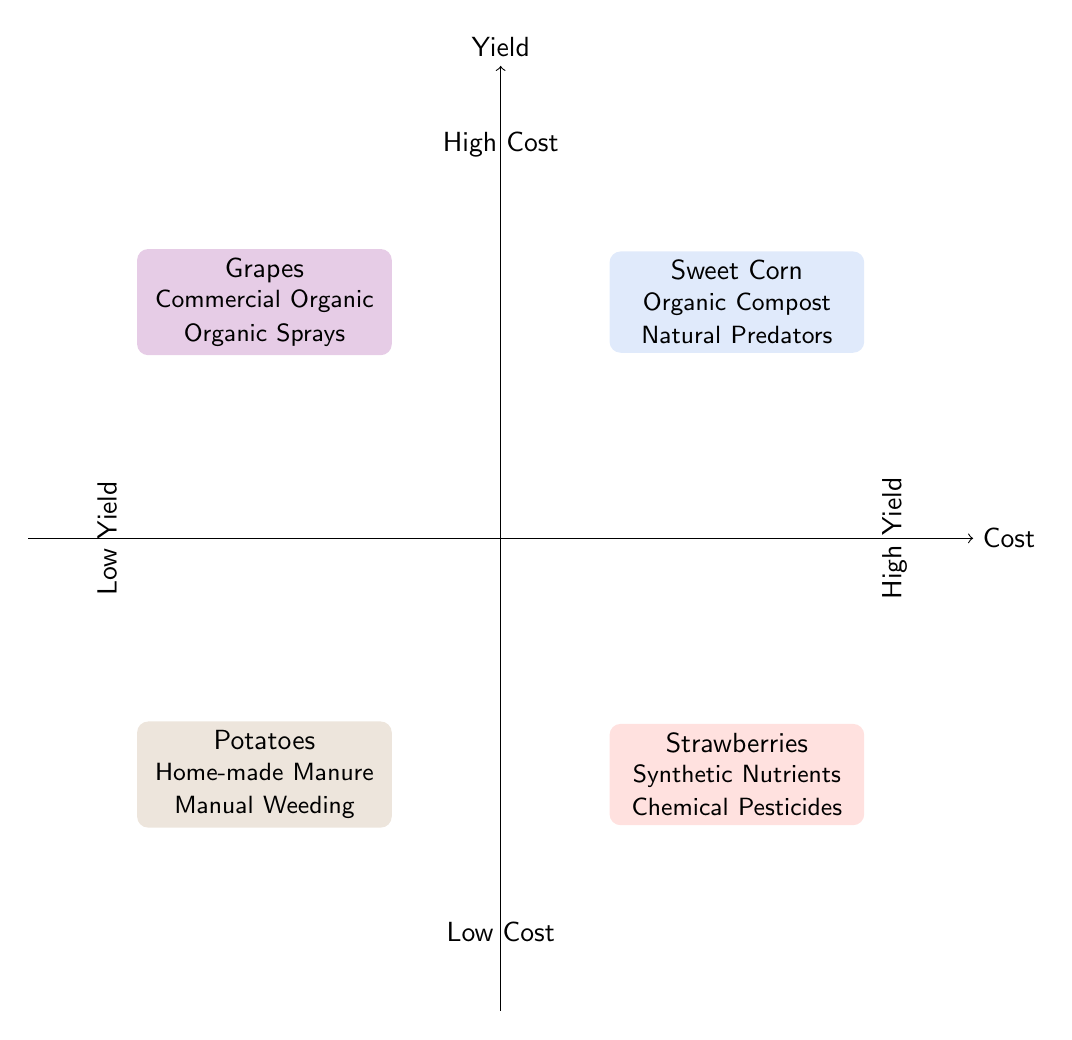What crop has high yield and low cost? The quadrant labeled "High Yield & Low Cost" contains the node for "Sweet Corn." This indicates that Sweet Corn is the crop that performs well in terms of yield while also being low in cost.
Answer: Sweet Corn Which crop has high yield but high cost? In the quadrant "High Yield & High Cost," the crop displayed is "Strawberries." This means Strawberries yield well but come with high costs associated with cultivation.
Answer: Strawberries What is the fertilizer used for low yield and high cost? Looking at the "Low Yield & High Cost" quadrant, the crop "Grapes" uses "Commercial Organic" as its fertilizer. Thus, this is the answer regarding the fertilizer for crops in that category.
Answer: Commercial Organic How many crops are represented in the diagram? There are a total of 4 distinct crops shown in the diagram: Sweet Corn, Strawberries, Potatoes, and Grapes, indicating that the diagram represents 4 crops overall.
Answer: 4 What pest control method is used for low yield and low cost? In the quadrant "Low Yield & Low Cost," the crop "Potatoes" employs "Manual Weeding" as its method for pest control. Thus, this method indicates how pest issues are managed for this crop type.
Answer: Manual Weeding Which quadrant is associated with high cost? The quadrants "High Yield & High Cost" and "Low Yield & High Cost" both demonstrate high cost. These two sections indicate that crops in these quadrants require more financial investment.
Answer: High Yield & High Cost and Low Yield & High Cost Name one crop that uses natural predators for pest control. Within the "High Yield & Low Cost" quadrant, "Sweet Corn" utilizes "Natural Predators" for pest management. This specific mention shows this method is effective for this crop’s cultivation.
Answer: Sweet Corn What relationship do potatoes and organic sprays have? The "Potatoes" crop, located in the "Low Yield & Low Cost" quadrant, does not use organic sprays; instead, it uses manual weeding. In contrast, organic sprays are used for "Grapes," found in the "Low Yield & High Cost" quadrant, thus indicating no direct relationship between them regarding pest control methods.
Answer: No relationship 